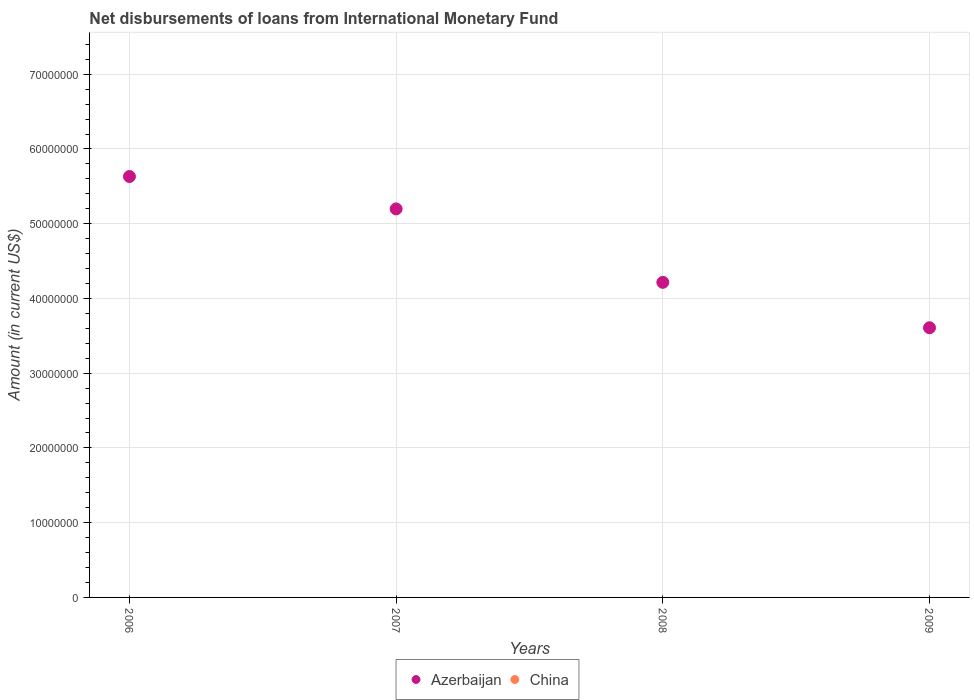Is the number of dotlines equal to the number of legend labels?
Your answer should be very brief. No. What is the amount of loans disbursed in China in 2008?
Offer a terse response. 0. Across all years, what is the maximum amount of loans disbursed in Azerbaijan?
Provide a succinct answer. 5.63e+07. Across all years, what is the minimum amount of loans disbursed in China?
Provide a succinct answer. 0. What is the total amount of loans disbursed in China in the graph?
Provide a short and direct response. 0. What is the difference between the amount of loans disbursed in Azerbaijan in 2007 and that in 2009?
Make the answer very short. 1.59e+07. What is the difference between the amount of loans disbursed in Azerbaijan in 2006 and the amount of loans disbursed in China in 2007?
Offer a very short reply. 5.63e+07. What is the average amount of loans disbursed in China per year?
Your answer should be compact. 0. In how many years, is the amount of loans disbursed in Azerbaijan greater than 42000000 US$?
Keep it short and to the point. 3. What is the ratio of the amount of loans disbursed in Azerbaijan in 2007 to that in 2009?
Make the answer very short. 1.44. Is the amount of loans disbursed in Azerbaijan in 2006 less than that in 2009?
Your answer should be very brief. No. What is the difference between the highest and the second highest amount of loans disbursed in Azerbaijan?
Ensure brevity in your answer.  4.33e+06. What is the difference between the highest and the lowest amount of loans disbursed in Azerbaijan?
Give a very brief answer. 2.02e+07. In how many years, is the amount of loans disbursed in Azerbaijan greater than the average amount of loans disbursed in Azerbaijan taken over all years?
Your answer should be compact. 2. Is the amount of loans disbursed in Azerbaijan strictly greater than the amount of loans disbursed in China over the years?
Offer a very short reply. Yes. How many dotlines are there?
Provide a short and direct response. 1. Are the values on the major ticks of Y-axis written in scientific E-notation?
Provide a short and direct response. No. Does the graph contain any zero values?
Your response must be concise. Yes. Where does the legend appear in the graph?
Make the answer very short. Bottom center. How many legend labels are there?
Provide a succinct answer. 2. What is the title of the graph?
Make the answer very short. Net disbursements of loans from International Monetary Fund. Does "Argentina" appear as one of the legend labels in the graph?
Your response must be concise. No. What is the Amount (in current US$) in Azerbaijan in 2006?
Your answer should be compact. 5.63e+07. What is the Amount (in current US$) of China in 2006?
Provide a short and direct response. 0. What is the Amount (in current US$) of Azerbaijan in 2007?
Provide a short and direct response. 5.20e+07. What is the Amount (in current US$) of Azerbaijan in 2008?
Provide a short and direct response. 4.22e+07. What is the Amount (in current US$) in Azerbaijan in 2009?
Give a very brief answer. 3.61e+07. Across all years, what is the maximum Amount (in current US$) of Azerbaijan?
Offer a terse response. 5.63e+07. Across all years, what is the minimum Amount (in current US$) of Azerbaijan?
Keep it short and to the point. 3.61e+07. What is the total Amount (in current US$) of Azerbaijan in the graph?
Keep it short and to the point. 1.87e+08. What is the difference between the Amount (in current US$) of Azerbaijan in 2006 and that in 2007?
Ensure brevity in your answer.  4.33e+06. What is the difference between the Amount (in current US$) of Azerbaijan in 2006 and that in 2008?
Offer a very short reply. 1.42e+07. What is the difference between the Amount (in current US$) in Azerbaijan in 2006 and that in 2009?
Make the answer very short. 2.02e+07. What is the difference between the Amount (in current US$) of Azerbaijan in 2007 and that in 2008?
Provide a succinct answer. 9.82e+06. What is the difference between the Amount (in current US$) of Azerbaijan in 2007 and that in 2009?
Your response must be concise. 1.59e+07. What is the difference between the Amount (in current US$) of Azerbaijan in 2008 and that in 2009?
Provide a succinct answer. 6.08e+06. What is the average Amount (in current US$) of Azerbaijan per year?
Your answer should be compact. 4.66e+07. What is the ratio of the Amount (in current US$) of Azerbaijan in 2006 to that in 2007?
Give a very brief answer. 1.08. What is the ratio of the Amount (in current US$) of Azerbaijan in 2006 to that in 2008?
Provide a short and direct response. 1.34. What is the ratio of the Amount (in current US$) in Azerbaijan in 2006 to that in 2009?
Provide a succinct answer. 1.56. What is the ratio of the Amount (in current US$) in Azerbaijan in 2007 to that in 2008?
Your response must be concise. 1.23. What is the ratio of the Amount (in current US$) in Azerbaijan in 2007 to that in 2009?
Your answer should be compact. 1.44. What is the ratio of the Amount (in current US$) of Azerbaijan in 2008 to that in 2009?
Provide a succinct answer. 1.17. What is the difference between the highest and the second highest Amount (in current US$) of Azerbaijan?
Provide a succinct answer. 4.33e+06. What is the difference between the highest and the lowest Amount (in current US$) in Azerbaijan?
Make the answer very short. 2.02e+07. 